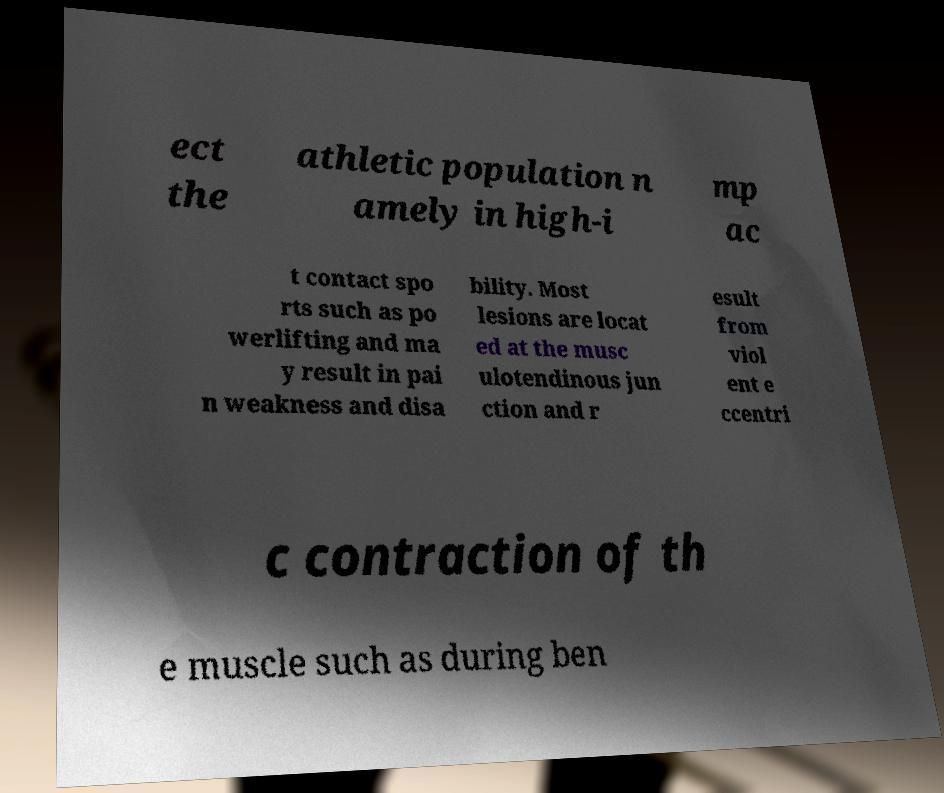For documentation purposes, I need the text within this image transcribed. Could you provide that? ect the athletic population n amely in high-i mp ac t contact spo rts such as po werlifting and ma y result in pai n weakness and disa bility. Most lesions are locat ed at the musc ulotendinous jun ction and r esult from viol ent e ccentri c contraction of th e muscle such as during ben 